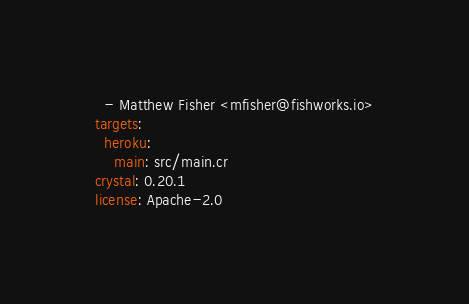<code> <loc_0><loc_0><loc_500><loc_500><_YAML_>  - Matthew Fisher <mfisher@fishworks.io>
targets:
  heroku:
    main: src/main.cr
crystal: 0.20.1
license: Apache-2.0
</code> 